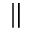Convert formula to latex. <formula><loc_0><loc_0><loc_500><loc_500>\|</formula> 